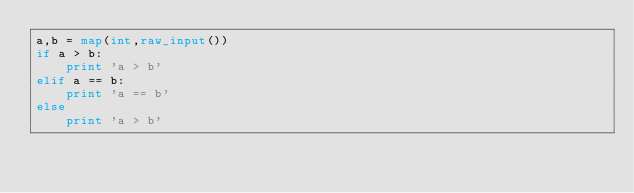<code> <loc_0><loc_0><loc_500><loc_500><_Python_>a,b = map(int,raw_input())
if a > b:
    print 'a > b'
elif a == b:
    print 'a == b'
else
    print 'a > b'</code> 